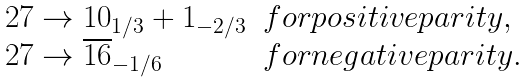<formula> <loc_0><loc_0><loc_500><loc_500>\begin{array} { l l } 2 7 \to 1 0 _ { 1 / 3 } + 1 _ { - 2 / 3 } & f o r p o s i t i v e p a r i t y , \\ 2 7 \to \overline { 1 6 } _ { - 1 / 6 } & f o r n e g a t i v e p a r i t y . \end{array}</formula> 